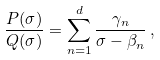<formula> <loc_0><loc_0><loc_500><loc_500>\frac { P ( \sigma ) } { Q ( \sigma ) } = \sum _ { n = 1 } ^ { d } \frac { \gamma _ { n } } { \sigma - \beta _ { n } } \, ,</formula> 